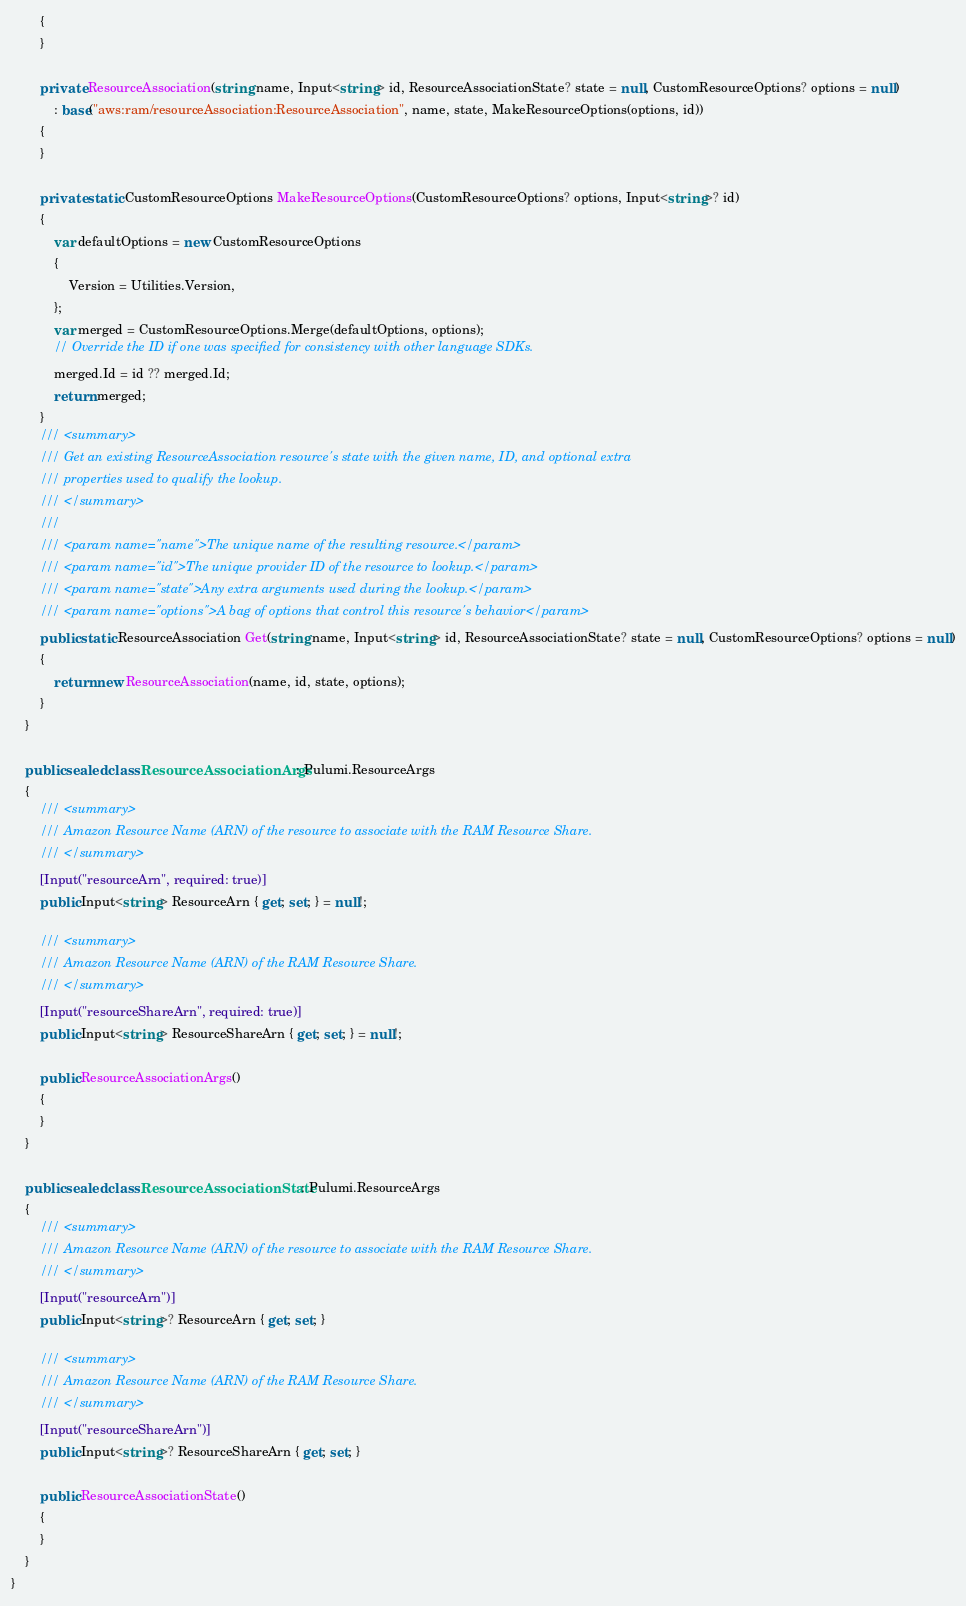Convert code to text. <code><loc_0><loc_0><loc_500><loc_500><_C#_>        {
        }

        private ResourceAssociation(string name, Input<string> id, ResourceAssociationState? state = null, CustomResourceOptions? options = null)
            : base("aws:ram/resourceAssociation:ResourceAssociation", name, state, MakeResourceOptions(options, id))
        {
        }

        private static CustomResourceOptions MakeResourceOptions(CustomResourceOptions? options, Input<string>? id)
        {
            var defaultOptions = new CustomResourceOptions
            {
                Version = Utilities.Version,
            };
            var merged = CustomResourceOptions.Merge(defaultOptions, options);
            // Override the ID if one was specified for consistency with other language SDKs.
            merged.Id = id ?? merged.Id;
            return merged;
        }
        /// <summary>
        /// Get an existing ResourceAssociation resource's state with the given name, ID, and optional extra
        /// properties used to qualify the lookup.
        /// </summary>
        ///
        /// <param name="name">The unique name of the resulting resource.</param>
        /// <param name="id">The unique provider ID of the resource to lookup.</param>
        /// <param name="state">Any extra arguments used during the lookup.</param>
        /// <param name="options">A bag of options that control this resource's behavior</param>
        public static ResourceAssociation Get(string name, Input<string> id, ResourceAssociationState? state = null, CustomResourceOptions? options = null)
        {
            return new ResourceAssociation(name, id, state, options);
        }
    }

    public sealed class ResourceAssociationArgs : Pulumi.ResourceArgs
    {
        /// <summary>
        /// Amazon Resource Name (ARN) of the resource to associate with the RAM Resource Share.
        /// </summary>
        [Input("resourceArn", required: true)]
        public Input<string> ResourceArn { get; set; } = null!;

        /// <summary>
        /// Amazon Resource Name (ARN) of the RAM Resource Share.
        /// </summary>
        [Input("resourceShareArn", required: true)]
        public Input<string> ResourceShareArn { get; set; } = null!;

        public ResourceAssociationArgs()
        {
        }
    }

    public sealed class ResourceAssociationState : Pulumi.ResourceArgs
    {
        /// <summary>
        /// Amazon Resource Name (ARN) of the resource to associate with the RAM Resource Share.
        /// </summary>
        [Input("resourceArn")]
        public Input<string>? ResourceArn { get; set; }

        /// <summary>
        /// Amazon Resource Name (ARN) of the RAM Resource Share.
        /// </summary>
        [Input("resourceShareArn")]
        public Input<string>? ResourceShareArn { get; set; }

        public ResourceAssociationState()
        {
        }
    }
}
</code> 